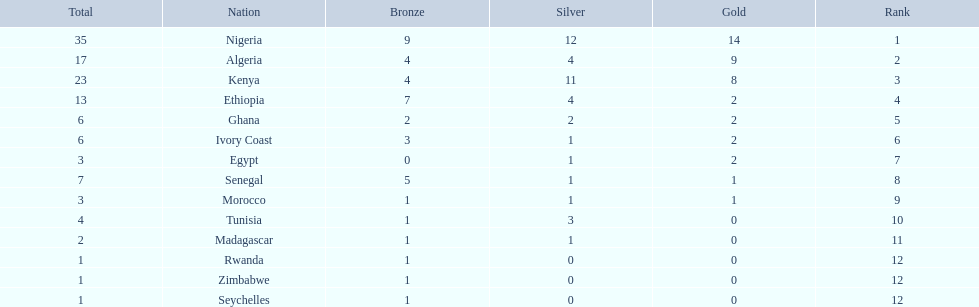Which nations competed in the 1989 african championships in athletics? Nigeria, Algeria, Kenya, Ethiopia, Ghana, Ivory Coast, Egypt, Senegal, Morocco, Tunisia, Madagascar, Rwanda, Zimbabwe, Seychelles. Of these nations, which earned 0 bronze medals? Egypt. 